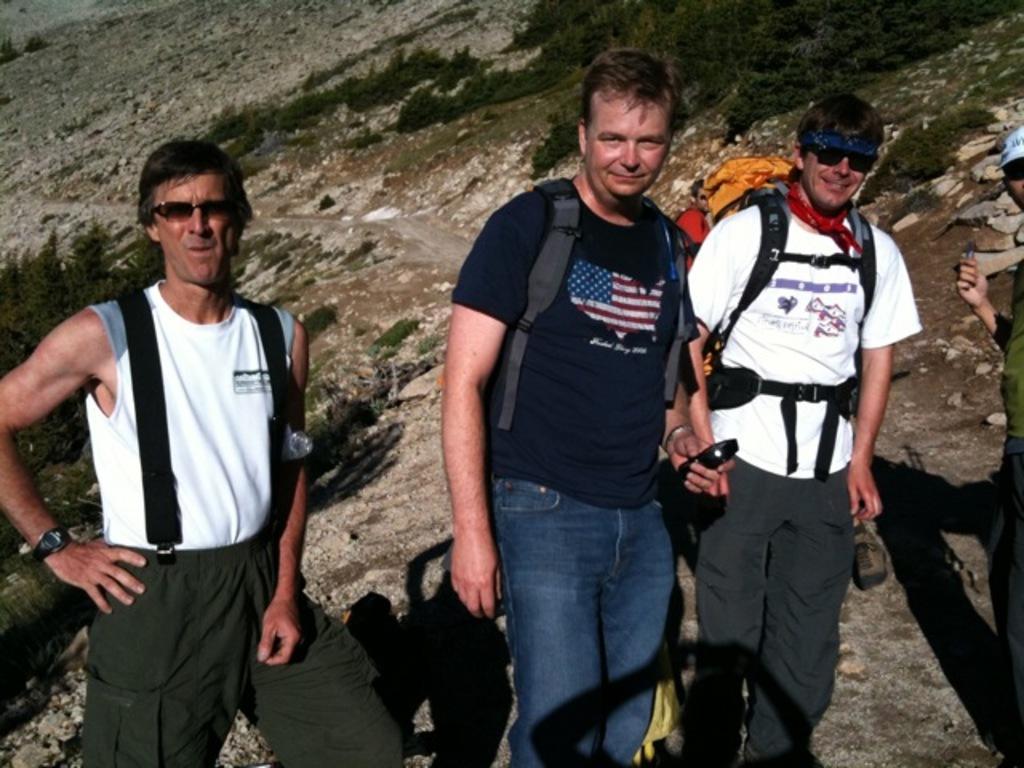In one or two sentences, can you explain what this image depicts? In this image, we can see people wearing bags and one of them is holding a mobile. In the background, we can see trees and hills. 